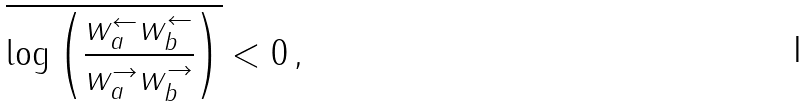Convert formula to latex. <formula><loc_0><loc_0><loc_500><loc_500>\overline { \log \left ( \frac { w _ { a } ^ { \leftarrow } w _ { b } ^ { \leftarrow } } { w _ { a } ^ { \rightarrow } w _ { b } ^ { \rightarrow } } \right ) } < 0 \, ,</formula> 